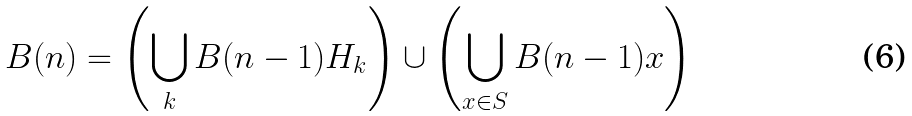<formula> <loc_0><loc_0><loc_500><loc_500>B ( n ) = \left ( \bigcup _ { k } B ( n - 1 ) H _ { k } \right ) \cup \left ( \bigcup _ { x \in S } B ( n - 1 ) x \right )</formula> 